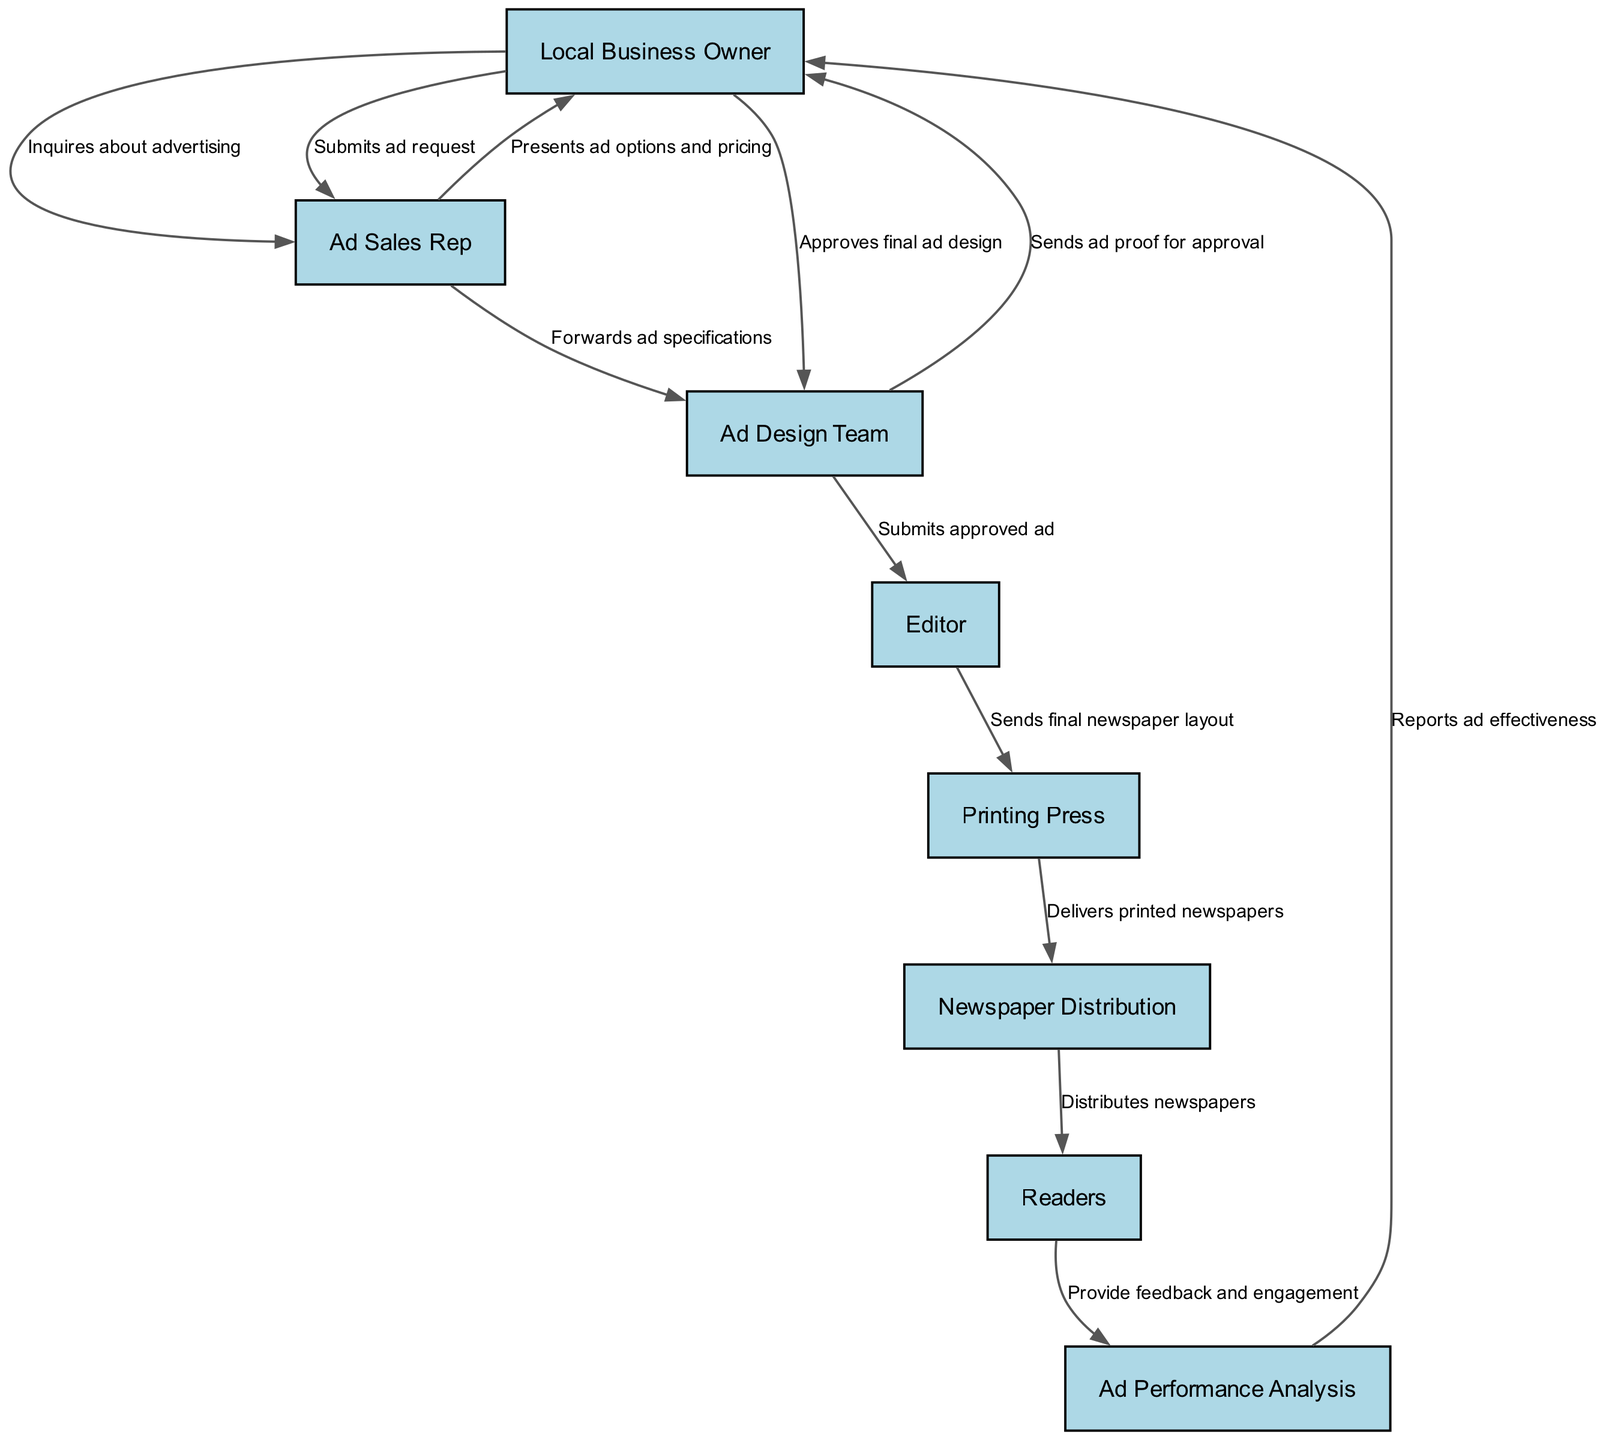What is the first node in the advertisement lifecycle? The first node is 'Local Business Owner', as it is the starting point where they inquire about advertising. This node initiates the entire process.
Answer: Local Business Owner How many total nodes are there in the diagram? By counting each unique entity in the nodes section, we determine that there are eight distinct nodes represented in the graph.
Answer: 8 What happens after the 'Ad Design Team' submits the approved ad? After the 'Ad Design Team' submits the approved ad, the next step is for the 'Editor' to receive this submission. This indicates the progression of the advertising process from design to editorial.
Answer: Editor Which node provides feedback to 'Ad Performance Analysis'? The node that provides feedback to 'Ad Performance Analysis' is 'Readers'. They give feedback and engagement data that is essential for analyzing the ad's performance.
Answer: Readers What is the relationship between 'Ad Sales Rep' and 'Local Business Owner'? The relationship is that 'Ad Sales Rep' presents ad options and pricing to 'Local Business Owner', and then the owner submits an ad request to the sales representative. This interaction is crucial for the acquisition phase of the advertisement lifecycle.
Answer: Presents ad options and pricing, Submits ad request Which node is directly connected to 'Printing Press'? The node that is directly connected to 'Printing Press' is 'Editor', as the editor sends the final newspaper layout to the printing press for production.
Answer: Editor What role does 'Ad Performance Analysis' play after 'Readers'? 'Ad Performance Analysis' plays a reporting role after 'Readers'; it assesses the feedback and reports the effectiveness of the ad to 'Local Business Owner', completing the feedback loop in the advertisement lifecycle.
Answer: Reports ad effectiveness How many edges connect 'Local Business Owner' to other nodes? Counting the edges that originate from 'Local Business Owner', we find that there are three connections leading from this node to others, indicating multiple interactions in the ad lifecycle.
Answer: 3 What do the 'Printing Press' and 'Newspaper Distribution' nodes have in common? Both nodes are involved in the physical production and distribution of the newspaper. 'Printing Press' is responsible for delivering printed newspapers, while 'Newspaper Distribution' handles the distribution to readers.
Answer: Both are involved in physical production and distribution 